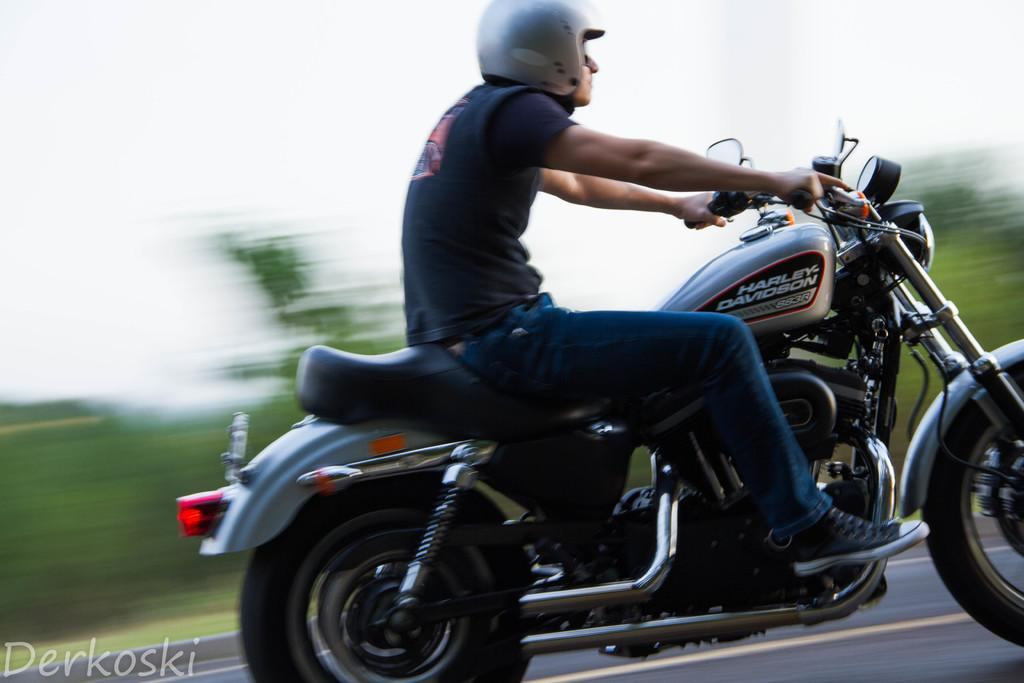What is the man in the image doing? The man is riding a bike in the image. Where is the man riding the bike? The man is on a road in the image. What type of clothing is the man wearing? The man is wearing a T-shirt, jeans, and shoes in the image. What can be seen in the background of the image? There are trees visible in the image. What type of toys can be seen in the man's backpack in the image? There is no backpack or toys present in the image. 